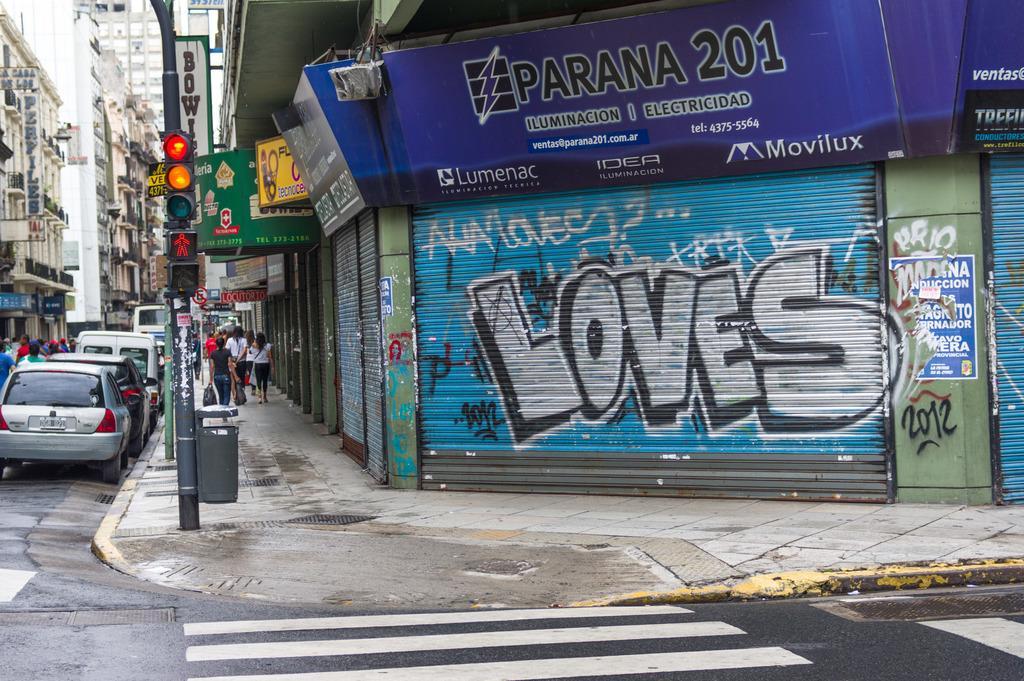Could you give a brief overview of what you see in this image? In this image there are vehicles on the road, there are group of people, there are traffic signal lights to the pole, there are boards , buildings, there is graffiti on the shutter. 